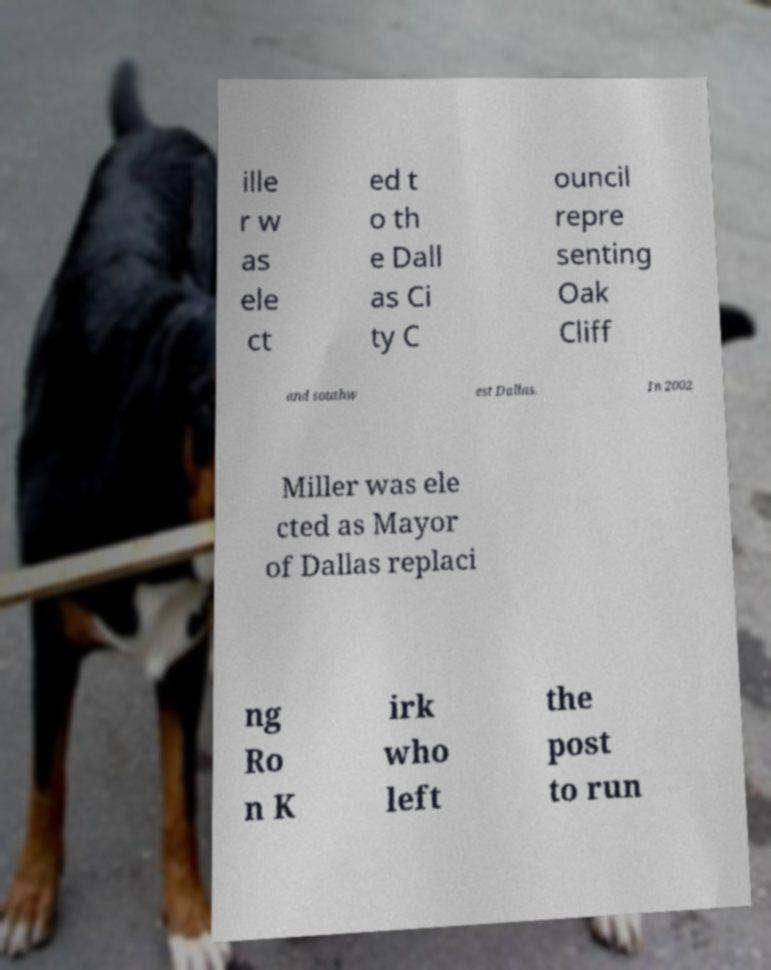For documentation purposes, I need the text within this image transcribed. Could you provide that? ille r w as ele ct ed t o th e Dall as Ci ty C ouncil repre senting Oak Cliff and southw est Dallas. In 2002 Miller was ele cted as Mayor of Dallas replaci ng Ro n K irk who left the post to run 